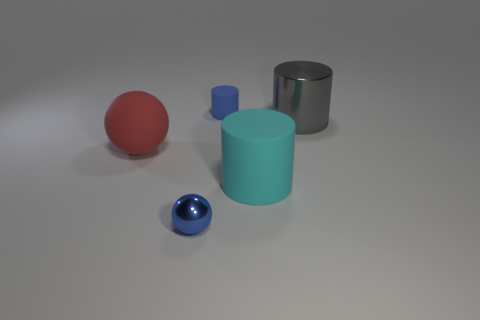What is the color of the metallic cylinder?
Give a very brief answer. Gray. How many rubber things are tiny blue spheres or green cylinders?
Provide a succinct answer. 0. Is there anything else that is made of the same material as the big ball?
Your answer should be compact. Yes. There is a shiny object that is behind the large cylinder in front of the big shiny thing that is to the right of the large cyan matte cylinder; what size is it?
Ensure brevity in your answer.  Large. There is a object that is on the left side of the cyan cylinder and behind the big red matte ball; what is its size?
Your response must be concise. Small. There is a rubber cylinder that is left of the cyan rubber cylinder; does it have the same color as the small object in front of the large matte sphere?
Offer a very short reply. Yes. How many large rubber cylinders are behind the large shiny thing?
Your response must be concise. 0. There is a big gray shiny object that is to the right of the small blue object in front of the metal cylinder; are there any blue objects that are behind it?
Your response must be concise. Yes. What number of cyan matte cylinders are the same size as the red rubber object?
Ensure brevity in your answer.  1. The big red sphere that is to the left of the cylinder to the left of the big cyan cylinder is made of what material?
Your answer should be compact. Rubber. 